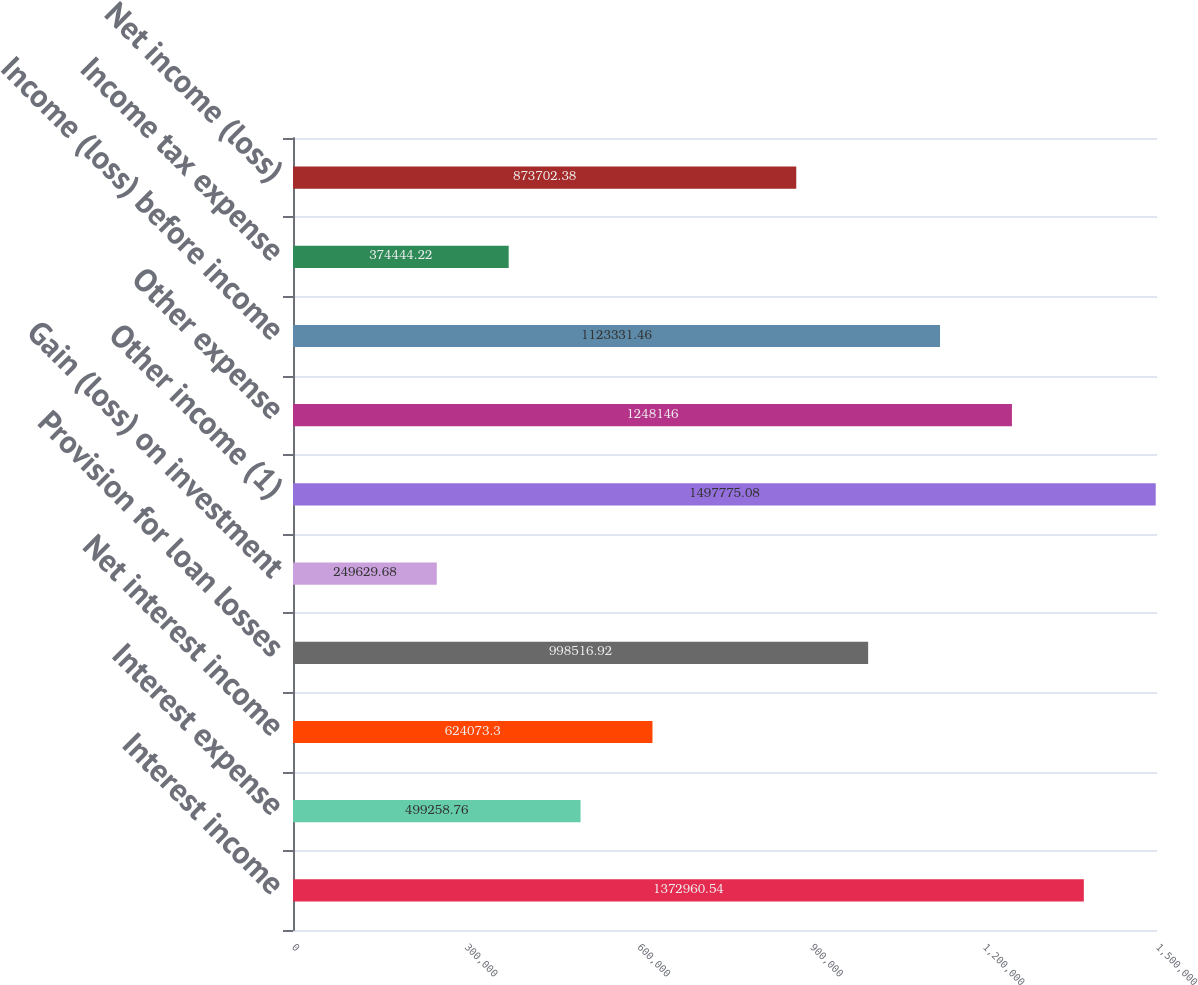Convert chart to OTSL. <chart><loc_0><loc_0><loc_500><loc_500><bar_chart><fcel>Interest income<fcel>Interest expense<fcel>Net interest income<fcel>Provision for loan losses<fcel>Gain (loss) on investment<fcel>Other income (1)<fcel>Other expense<fcel>Income (loss) before income<fcel>Income tax expense<fcel>Net income (loss)<nl><fcel>1.37296e+06<fcel>499259<fcel>624073<fcel>998517<fcel>249630<fcel>1.49778e+06<fcel>1.24815e+06<fcel>1.12333e+06<fcel>374444<fcel>873702<nl></chart> 